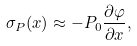Convert formula to latex. <formula><loc_0><loc_0><loc_500><loc_500>\sigma _ { P } ( x ) \approx - P _ { 0 } \frac { \partial \varphi } { \partial x } ,</formula> 